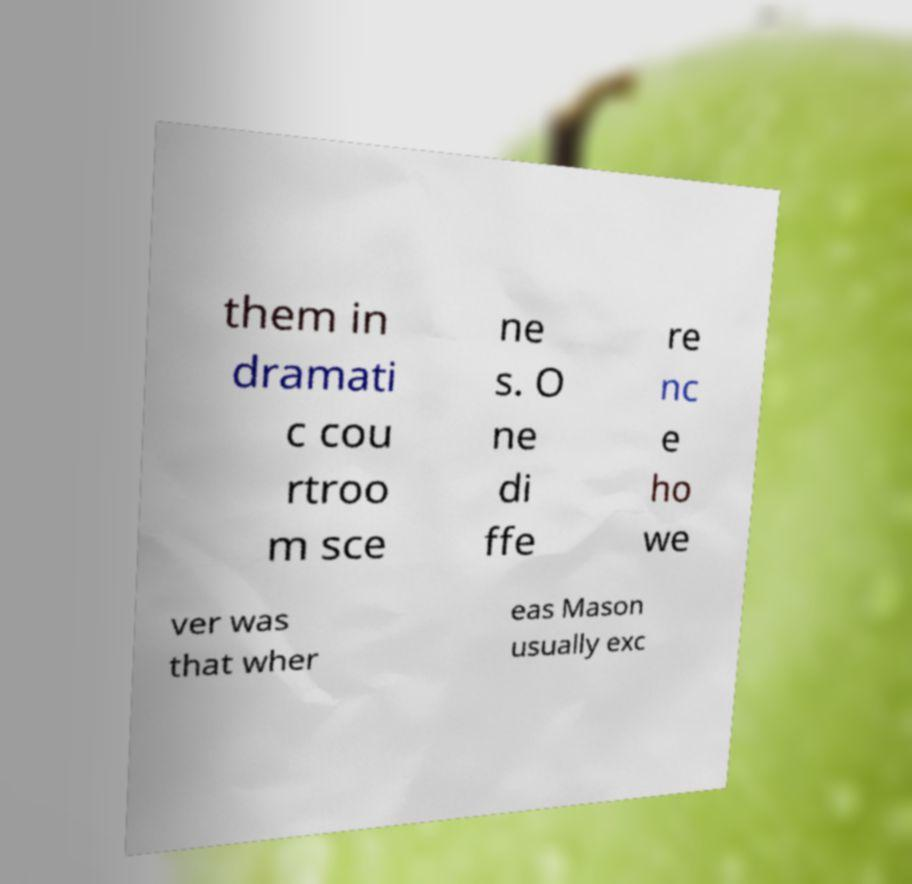For documentation purposes, I need the text within this image transcribed. Could you provide that? them in dramati c cou rtroo m sce ne s. O ne di ffe re nc e ho we ver was that wher eas Mason usually exc 